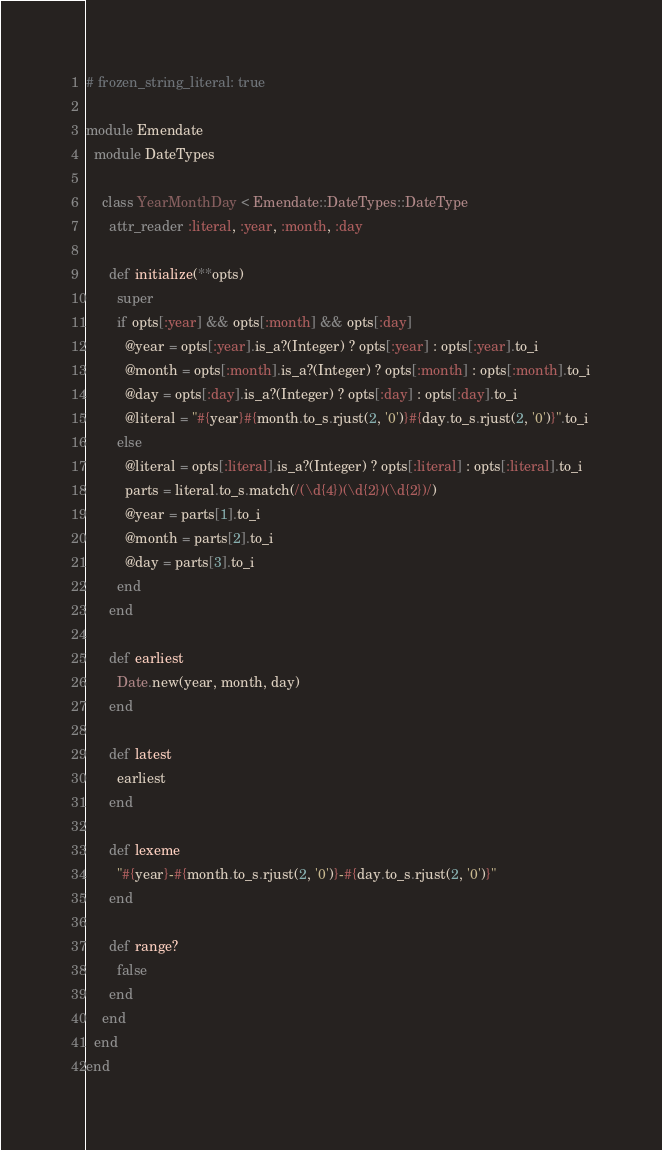Convert code to text. <code><loc_0><loc_0><loc_500><loc_500><_Ruby_># frozen_string_literal: true

module Emendate
  module DateTypes

    class YearMonthDay < Emendate::DateTypes::DateType
      attr_reader :literal, :year, :month, :day

      def initialize(**opts)
        super
        if opts[:year] && opts[:month] && opts[:day]
          @year = opts[:year].is_a?(Integer) ? opts[:year] : opts[:year].to_i
          @month = opts[:month].is_a?(Integer) ? opts[:month] : opts[:month].to_i
          @day = opts[:day].is_a?(Integer) ? opts[:day] : opts[:day].to_i
          @literal = "#{year}#{month.to_s.rjust(2, '0')}#{day.to_s.rjust(2, '0')}".to_i
        else
          @literal = opts[:literal].is_a?(Integer) ? opts[:literal] : opts[:literal].to_i
          parts = literal.to_s.match(/(\d{4})(\d{2})(\d{2})/)
          @year = parts[1].to_i
          @month = parts[2].to_i
          @day = parts[3].to_i
        end
      end

      def earliest
        Date.new(year, month, day)
      end

      def latest
        earliest
      end

      def lexeme
        "#{year}-#{month.to_s.rjust(2, '0')}-#{day.to_s.rjust(2, '0')}"
      end

      def range?
        false
      end
    end
  end
end
</code> 